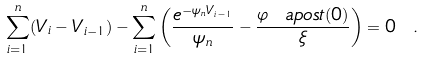<formula> <loc_0><loc_0><loc_500><loc_500>\sum _ { i = 1 } ^ { n } ( V _ { i } - V _ { i - 1 } ) - \sum _ { i = 1 } ^ { n } \left ( \frac { e ^ { - \psi _ { n } V _ { i - 1 } } } { \psi _ { n } } - \frac { \varphi \ a p o s t ( 0 ) } { \xi } \right ) = 0 \ .</formula> 